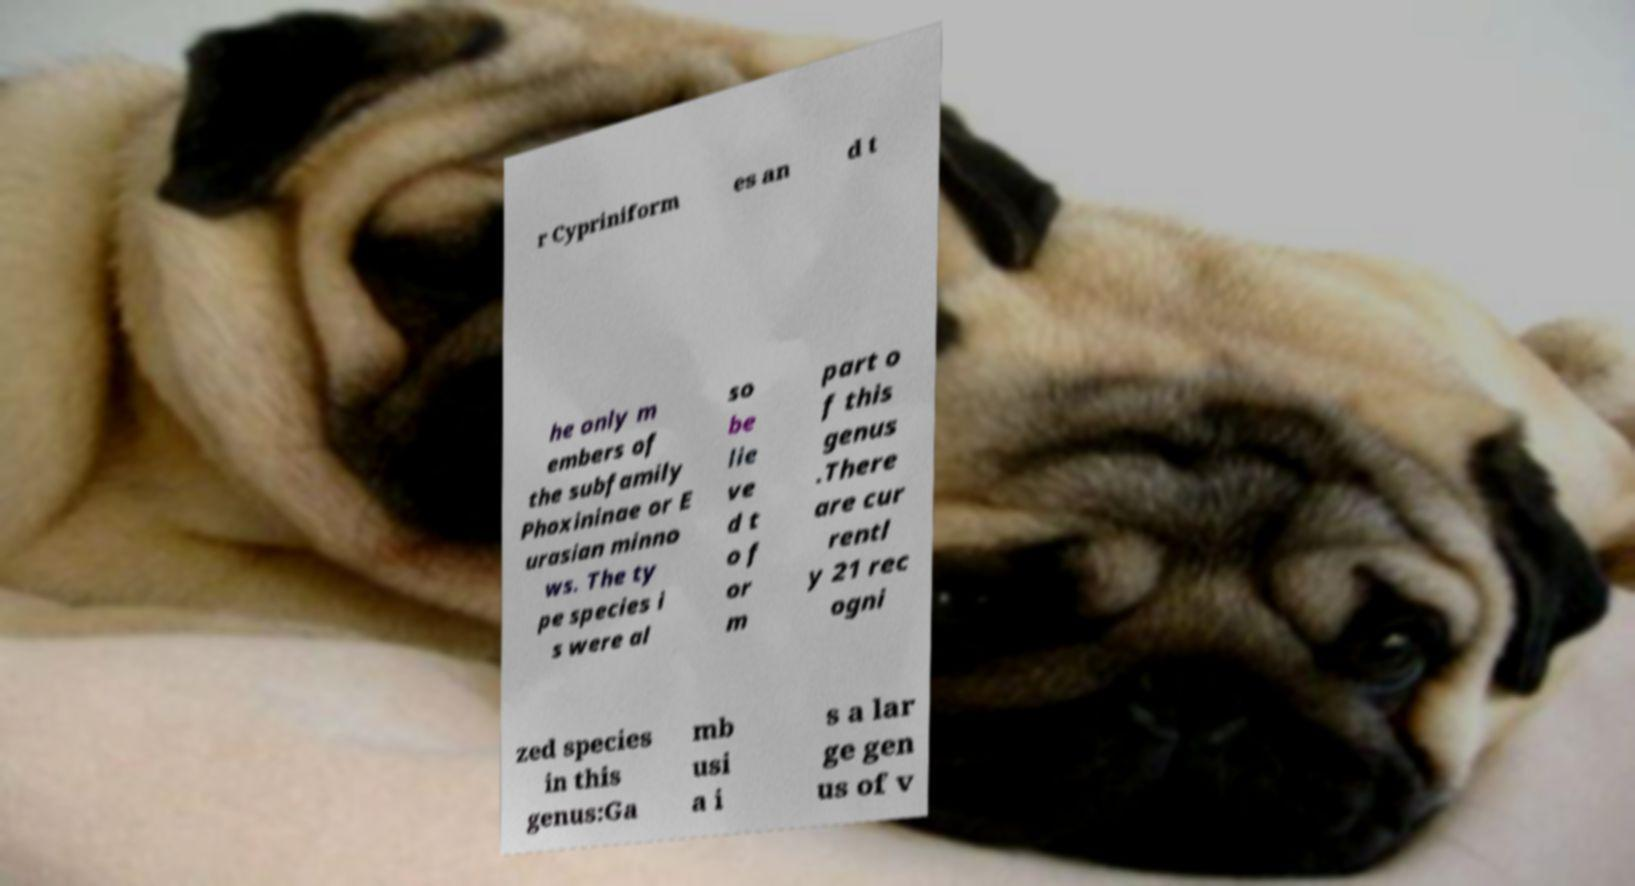Please identify and transcribe the text found in this image. r Cypriniform es an d t he only m embers of the subfamily Phoxininae or E urasian minno ws. The ty pe species i s were al so be lie ve d t o f or m part o f this genus .There are cur rentl y 21 rec ogni zed species in this genus:Ga mb usi a i s a lar ge gen us of v 